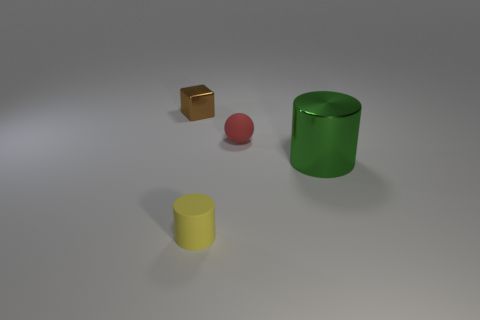There is a tiny matte object that is on the right side of the rubber cylinder; does it have the same shape as the metal object on the right side of the tiny matte sphere?
Your answer should be very brief. No. What number of blocks are red matte objects or large metal objects?
Make the answer very short. 0. What material is the object to the right of the matte object on the right side of the small rubber object that is in front of the green shiny cylinder?
Make the answer very short. Metal. What number of other objects are the same size as the brown block?
Make the answer very short. 2. Are there more small rubber things that are in front of the large green metal cylinder than yellow objects?
Your answer should be compact. No. Is there a big rubber cylinder that has the same color as the rubber ball?
Provide a short and direct response. No. What is the color of the ball that is the same size as the shiny cube?
Provide a succinct answer. Red. There is a shiny thing that is on the right side of the cube; how many small matte cylinders are behind it?
Your response must be concise. 0. What number of objects are either metal things that are in front of the matte ball or tiny yellow rubber things?
Provide a succinct answer. 2. What number of brown blocks have the same material as the green thing?
Offer a very short reply. 1. 